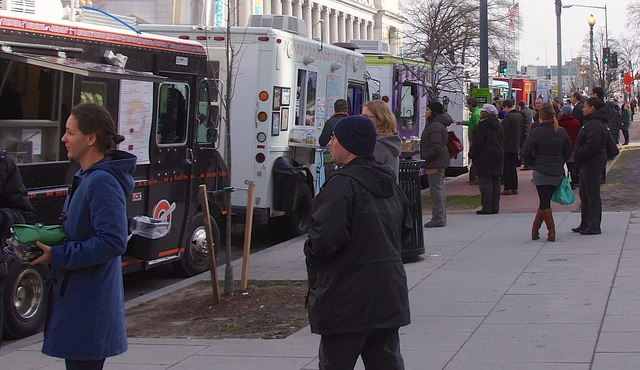Describe the objects in this image and their specific colors. I can see truck in purple, black, gray, darkgray, and maroon tones, truck in purple, darkgray, black, gray, and lightgray tones, people in purple, black, gray, and maroon tones, people in purple, black, navy, and maroon tones, and truck in purple, darkgray, gray, and black tones in this image. 